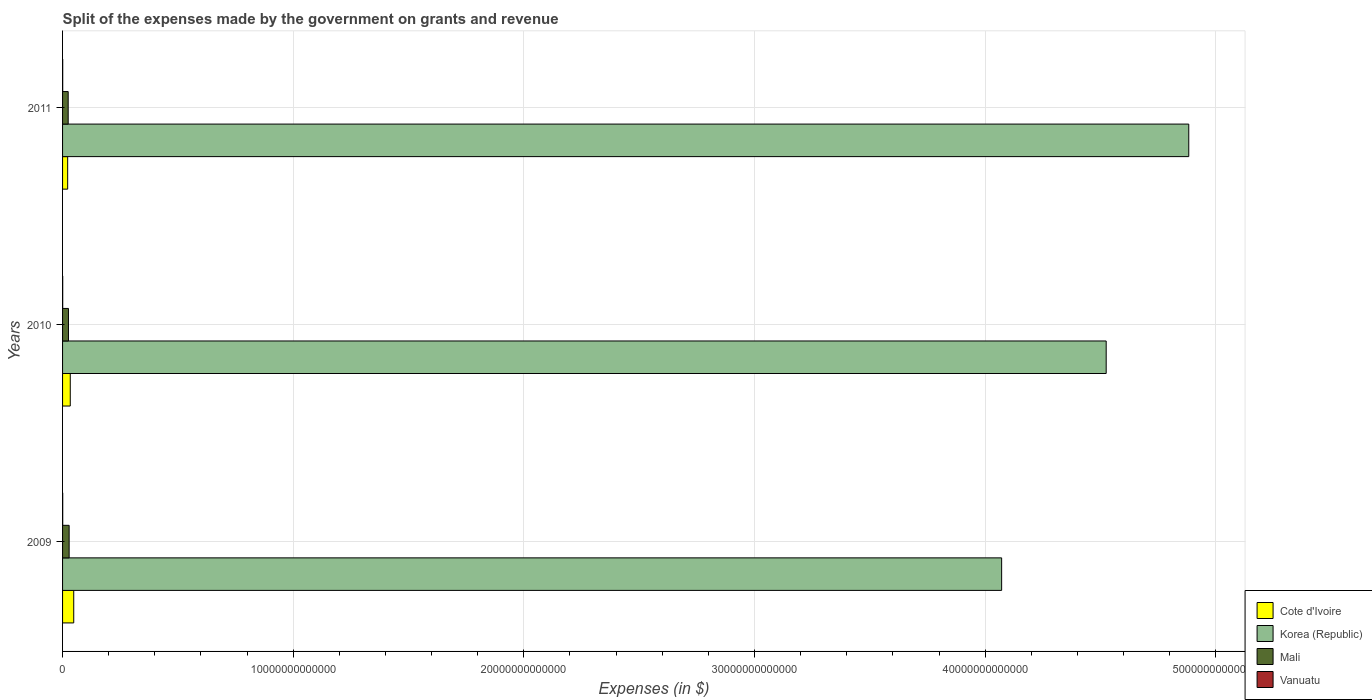How many different coloured bars are there?
Your answer should be very brief. 4. Are the number of bars per tick equal to the number of legend labels?
Keep it short and to the point. Yes. Are the number of bars on each tick of the Y-axis equal?
Your answer should be very brief. Yes. How many bars are there on the 2nd tick from the top?
Ensure brevity in your answer.  4. How many bars are there on the 3rd tick from the bottom?
Make the answer very short. 4. What is the expenses made by the government on grants and revenue in Cote d'Ivoire in 2011?
Your response must be concise. 2.21e+11. Across all years, what is the maximum expenses made by the government on grants and revenue in Korea (Republic)?
Provide a short and direct response. 4.88e+13. Across all years, what is the minimum expenses made by the government on grants and revenue in Korea (Republic)?
Provide a succinct answer. 4.07e+13. In which year was the expenses made by the government on grants and revenue in Vanuatu minimum?
Your response must be concise. 2011. What is the total expenses made by the government on grants and revenue in Korea (Republic) in the graph?
Offer a very short reply. 1.35e+14. What is the difference between the expenses made by the government on grants and revenue in Korea (Republic) in 2010 and that in 2011?
Keep it short and to the point. -3.58e+12. What is the difference between the expenses made by the government on grants and revenue in Korea (Republic) in 2010 and the expenses made by the government on grants and revenue in Cote d'Ivoire in 2009?
Offer a terse response. 4.48e+13. What is the average expenses made by the government on grants and revenue in Mali per year?
Keep it short and to the point. 2.62e+11. In the year 2011, what is the difference between the expenses made by the government on grants and revenue in Cote d'Ivoire and expenses made by the government on grants and revenue in Korea (Republic)?
Keep it short and to the point. -4.86e+13. In how many years, is the expenses made by the government on grants and revenue in Mali greater than 20000000000000 $?
Your response must be concise. 0. What is the ratio of the expenses made by the government on grants and revenue in Vanuatu in 2009 to that in 2010?
Make the answer very short. 1.04. Is the expenses made by the government on grants and revenue in Korea (Republic) in 2009 less than that in 2011?
Your response must be concise. Yes. Is the difference between the expenses made by the government on grants and revenue in Cote d'Ivoire in 2010 and 2011 greater than the difference between the expenses made by the government on grants and revenue in Korea (Republic) in 2010 and 2011?
Ensure brevity in your answer.  Yes. What is the difference between the highest and the second highest expenses made by the government on grants and revenue in Vanuatu?
Ensure brevity in your answer.  2.76e+08. What is the difference between the highest and the lowest expenses made by the government on grants and revenue in Korea (Republic)?
Your answer should be compact. 8.11e+12. In how many years, is the expenses made by the government on grants and revenue in Korea (Republic) greater than the average expenses made by the government on grants and revenue in Korea (Republic) taken over all years?
Ensure brevity in your answer.  2. Is it the case that in every year, the sum of the expenses made by the government on grants and revenue in Vanuatu and expenses made by the government on grants and revenue in Cote d'Ivoire is greater than the sum of expenses made by the government on grants and revenue in Korea (Republic) and expenses made by the government on grants and revenue in Mali?
Make the answer very short. No. What does the 4th bar from the top in 2010 represents?
Provide a short and direct response. Cote d'Ivoire. Is it the case that in every year, the sum of the expenses made by the government on grants and revenue in Korea (Republic) and expenses made by the government on grants and revenue in Vanuatu is greater than the expenses made by the government on grants and revenue in Cote d'Ivoire?
Give a very brief answer. Yes. How many years are there in the graph?
Ensure brevity in your answer.  3. What is the difference between two consecutive major ticks on the X-axis?
Make the answer very short. 1.00e+13. Are the values on the major ticks of X-axis written in scientific E-notation?
Make the answer very short. No. Does the graph contain any zero values?
Your answer should be compact. No. Does the graph contain grids?
Make the answer very short. Yes. Where does the legend appear in the graph?
Offer a terse response. Bottom right. How many legend labels are there?
Make the answer very short. 4. What is the title of the graph?
Make the answer very short. Split of the expenses made by the government on grants and revenue. Does "Canada" appear as one of the legend labels in the graph?
Provide a short and direct response. No. What is the label or title of the X-axis?
Keep it short and to the point. Expenses (in $). What is the label or title of the Y-axis?
Offer a very short reply. Years. What is the Expenses (in $) of Cote d'Ivoire in 2009?
Offer a terse response. 4.84e+11. What is the Expenses (in $) in Korea (Republic) in 2009?
Ensure brevity in your answer.  4.07e+13. What is the Expenses (in $) of Mali in 2009?
Provide a short and direct response. 2.85e+11. What is the Expenses (in $) of Vanuatu in 2009?
Your response must be concise. 6.46e+09. What is the Expenses (in $) of Cote d'Ivoire in 2010?
Provide a short and direct response. 3.34e+11. What is the Expenses (in $) of Korea (Republic) in 2010?
Keep it short and to the point. 4.52e+13. What is the Expenses (in $) of Mali in 2010?
Offer a very short reply. 2.56e+11. What is the Expenses (in $) in Vanuatu in 2010?
Make the answer very short. 6.19e+09. What is the Expenses (in $) in Cote d'Ivoire in 2011?
Offer a very short reply. 2.21e+11. What is the Expenses (in $) in Korea (Republic) in 2011?
Your response must be concise. 4.88e+13. What is the Expenses (in $) of Mali in 2011?
Your response must be concise. 2.44e+11. What is the Expenses (in $) in Vanuatu in 2011?
Your answer should be very brief. 6.12e+09. Across all years, what is the maximum Expenses (in $) of Cote d'Ivoire?
Provide a succinct answer. 4.84e+11. Across all years, what is the maximum Expenses (in $) in Korea (Republic)?
Provide a short and direct response. 4.88e+13. Across all years, what is the maximum Expenses (in $) of Mali?
Offer a terse response. 2.85e+11. Across all years, what is the maximum Expenses (in $) of Vanuatu?
Your answer should be very brief. 6.46e+09. Across all years, what is the minimum Expenses (in $) in Cote d'Ivoire?
Offer a terse response. 2.21e+11. Across all years, what is the minimum Expenses (in $) of Korea (Republic)?
Offer a terse response. 4.07e+13. Across all years, what is the minimum Expenses (in $) in Mali?
Give a very brief answer. 2.44e+11. Across all years, what is the minimum Expenses (in $) in Vanuatu?
Make the answer very short. 6.12e+09. What is the total Expenses (in $) in Cote d'Ivoire in the graph?
Your answer should be very brief. 1.04e+12. What is the total Expenses (in $) in Korea (Republic) in the graph?
Keep it short and to the point. 1.35e+14. What is the total Expenses (in $) of Mali in the graph?
Make the answer very short. 7.85e+11. What is the total Expenses (in $) in Vanuatu in the graph?
Your answer should be compact. 1.88e+1. What is the difference between the Expenses (in $) of Cote d'Ivoire in 2009 and that in 2010?
Your answer should be compact. 1.50e+11. What is the difference between the Expenses (in $) in Korea (Republic) in 2009 and that in 2010?
Your response must be concise. -4.53e+12. What is the difference between the Expenses (in $) of Mali in 2009 and that in 2010?
Ensure brevity in your answer.  2.96e+1. What is the difference between the Expenses (in $) in Vanuatu in 2009 and that in 2010?
Make the answer very short. 2.76e+08. What is the difference between the Expenses (in $) of Cote d'Ivoire in 2009 and that in 2011?
Offer a terse response. 2.63e+11. What is the difference between the Expenses (in $) of Korea (Republic) in 2009 and that in 2011?
Your answer should be very brief. -8.11e+12. What is the difference between the Expenses (in $) in Mali in 2009 and that in 2011?
Provide a short and direct response. 4.14e+1. What is the difference between the Expenses (in $) of Vanuatu in 2009 and that in 2011?
Offer a terse response. 3.48e+08. What is the difference between the Expenses (in $) in Cote d'Ivoire in 2010 and that in 2011?
Ensure brevity in your answer.  1.13e+11. What is the difference between the Expenses (in $) in Korea (Republic) in 2010 and that in 2011?
Your response must be concise. -3.58e+12. What is the difference between the Expenses (in $) in Mali in 2010 and that in 2011?
Your answer should be compact. 1.18e+1. What is the difference between the Expenses (in $) of Vanuatu in 2010 and that in 2011?
Provide a short and direct response. 7.18e+07. What is the difference between the Expenses (in $) of Cote d'Ivoire in 2009 and the Expenses (in $) of Korea (Republic) in 2010?
Provide a succinct answer. -4.48e+13. What is the difference between the Expenses (in $) of Cote d'Ivoire in 2009 and the Expenses (in $) of Mali in 2010?
Keep it short and to the point. 2.28e+11. What is the difference between the Expenses (in $) in Cote d'Ivoire in 2009 and the Expenses (in $) in Vanuatu in 2010?
Offer a very short reply. 4.78e+11. What is the difference between the Expenses (in $) in Korea (Republic) in 2009 and the Expenses (in $) in Mali in 2010?
Provide a succinct answer. 4.05e+13. What is the difference between the Expenses (in $) of Korea (Republic) in 2009 and the Expenses (in $) of Vanuatu in 2010?
Your answer should be compact. 4.07e+13. What is the difference between the Expenses (in $) of Mali in 2009 and the Expenses (in $) of Vanuatu in 2010?
Ensure brevity in your answer.  2.79e+11. What is the difference between the Expenses (in $) of Cote d'Ivoire in 2009 and the Expenses (in $) of Korea (Republic) in 2011?
Ensure brevity in your answer.  -4.83e+13. What is the difference between the Expenses (in $) in Cote d'Ivoire in 2009 and the Expenses (in $) in Mali in 2011?
Offer a very short reply. 2.40e+11. What is the difference between the Expenses (in $) in Cote d'Ivoire in 2009 and the Expenses (in $) in Vanuatu in 2011?
Offer a terse response. 4.78e+11. What is the difference between the Expenses (in $) of Korea (Republic) in 2009 and the Expenses (in $) of Mali in 2011?
Your response must be concise. 4.05e+13. What is the difference between the Expenses (in $) of Korea (Republic) in 2009 and the Expenses (in $) of Vanuatu in 2011?
Offer a very short reply. 4.07e+13. What is the difference between the Expenses (in $) in Mali in 2009 and the Expenses (in $) in Vanuatu in 2011?
Your answer should be very brief. 2.79e+11. What is the difference between the Expenses (in $) in Cote d'Ivoire in 2010 and the Expenses (in $) in Korea (Republic) in 2011?
Provide a short and direct response. -4.85e+13. What is the difference between the Expenses (in $) of Cote d'Ivoire in 2010 and the Expenses (in $) of Mali in 2011?
Offer a very short reply. 8.99e+1. What is the difference between the Expenses (in $) in Cote d'Ivoire in 2010 and the Expenses (in $) in Vanuatu in 2011?
Make the answer very short. 3.28e+11. What is the difference between the Expenses (in $) in Korea (Republic) in 2010 and the Expenses (in $) in Mali in 2011?
Make the answer very short. 4.50e+13. What is the difference between the Expenses (in $) in Korea (Republic) in 2010 and the Expenses (in $) in Vanuatu in 2011?
Provide a succinct answer. 4.52e+13. What is the difference between the Expenses (in $) of Mali in 2010 and the Expenses (in $) of Vanuatu in 2011?
Offer a very short reply. 2.50e+11. What is the average Expenses (in $) of Cote d'Ivoire per year?
Give a very brief answer. 3.46e+11. What is the average Expenses (in $) of Korea (Republic) per year?
Your answer should be compact. 4.49e+13. What is the average Expenses (in $) in Mali per year?
Your answer should be compact. 2.62e+11. What is the average Expenses (in $) of Vanuatu per year?
Give a very brief answer. 6.26e+09. In the year 2009, what is the difference between the Expenses (in $) of Cote d'Ivoire and Expenses (in $) of Korea (Republic)?
Your response must be concise. -4.02e+13. In the year 2009, what is the difference between the Expenses (in $) in Cote d'Ivoire and Expenses (in $) in Mali?
Your answer should be very brief. 1.99e+11. In the year 2009, what is the difference between the Expenses (in $) in Cote d'Ivoire and Expenses (in $) in Vanuatu?
Give a very brief answer. 4.78e+11. In the year 2009, what is the difference between the Expenses (in $) of Korea (Republic) and Expenses (in $) of Mali?
Your response must be concise. 4.04e+13. In the year 2009, what is the difference between the Expenses (in $) of Korea (Republic) and Expenses (in $) of Vanuatu?
Give a very brief answer. 4.07e+13. In the year 2009, what is the difference between the Expenses (in $) in Mali and Expenses (in $) in Vanuatu?
Provide a succinct answer. 2.79e+11. In the year 2010, what is the difference between the Expenses (in $) of Cote d'Ivoire and Expenses (in $) of Korea (Republic)?
Offer a very short reply. -4.49e+13. In the year 2010, what is the difference between the Expenses (in $) of Cote d'Ivoire and Expenses (in $) of Mali?
Offer a terse response. 7.81e+1. In the year 2010, what is the difference between the Expenses (in $) in Cote d'Ivoire and Expenses (in $) in Vanuatu?
Offer a terse response. 3.28e+11. In the year 2010, what is the difference between the Expenses (in $) in Korea (Republic) and Expenses (in $) in Mali?
Ensure brevity in your answer.  4.50e+13. In the year 2010, what is the difference between the Expenses (in $) in Korea (Republic) and Expenses (in $) in Vanuatu?
Make the answer very short. 4.52e+13. In the year 2010, what is the difference between the Expenses (in $) in Mali and Expenses (in $) in Vanuatu?
Your response must be concise. 2.49e+11. In the year 2011, what is the difference between the Expenses (in $) in Cote d'Ivoire and Expenses (in $) in Korea (Republic)?
Your response must be concise. -4.86e+13. In the year 2011, what is the difference between the Expenses (in $) of Cote d'Ivoire and Expenses (in $) of Mali?
Make the answer very short. -2.27e+1. In the year 2011, what is the difference between the Expenses (in $) of Cote d'Ivoire and Expenses (in $) of Vanuatu?
Keep it short and to the point. 2.15e+11. In the year 2011, what is the difference between the Expenses (in $) in Korea (Republic) and Expenses (in $) in Mali?
Your response must be concise. 4.86e+13. In the year 2011, what is the difference between the Expenses (in $) in Korea (Republic) and Expenses (in $) in Vanuatu?
Provide a succinct answer. 4.88e+13. In the year 2011, what is the difference between the Expenses (in $) in Mali and Expenses (in $) in Vanuatu?
Your answer should be compact. 2.38e+11. What is the ratio of the Expenses (in $) of Cote d'Ivoire in 2009 to that in 2010?
Offer a terse response. 1.45. What is the ratio of the Expenses (in $) in Korea (Republic) in 2009 to that in 2010?
Keep it short and to the point. 0.9. What is the ratio of the Expenses (in $) in Mali in 2009 to that in 2010?
Offer a terse response. 1.12. What is the ratio of the Expenses (in $) in Vanuatu in 2009 to that in 2010?
Provide a succinct answer. 1.04. What is the ratio of the Expenses (in $) in Cote d'Ivoire in 2009 to that in 2011?
Your answer should be compact. 2.19. What is the ratio of the Expenses (in $) in Korea (Republic) in 2009 to that in 2011?
Provide a short and direct response. 0.83. What is the ratio of the Expenses (in $) of Mali in 2009 to that in 2011?
Offer a very short reply. 1.17. What is the ratio of the Expenses (in $) of Vanuatu in 2009 to that in 2011?
Offer a very short reply. 1.06. What is the ratio of the Expenses (in $) in Cote d'Ivoire in 2010 to that in 2011?
Your answer should be compact. 1.51. What is the ratio of the Expenses (in $) of Korea (Republic) in 2010 to that in 2011?
Keep it short and to the point. 0.93. What is the ratio of the Expenses (in $) in Mali in 2010 to that in 2011?
Make the answer very short. 1.05. What is the ratio of the Expenses (in $) in Vanuatu in 2010 to that in 2011?
Give a very brief answer. 1.01. What is the difference between the highest and the second highest Expenses (in $) in Cote d'Ivoire?
Offer a terse response. 1.50e+11. What is the difference between the highest and the second highest Expenses (in $) of Korea (Republic)?
Offer a very short reply. 3.58e+12. What is the difference between the highest and the second highest Expenses (in $) of Mali?
Make the answer very short. 2.96e+1. What is the difference between the highest and the second highest Expenses (in $) in Vanuatu?
Provide a succinct answer. 2.76e+08. What is the difference between the highest and the lowest Expenses (in $) in Cote d'Ivoire?
Keep it short and to the point. 2.63e+11. What is the difference between the highest and the lowest Expenses (in $) in Korea (Republic)?
Make the answer very short. 8.11e+12. What is the difference between the highest and the lowest Expenses (in $) in Mali?
Provide a short and direct response. 4.14e+1. What is the difference between the highest and the lowest Expenses (in $) in Vanuatu?
Make the answer very short. 3.48e+08. 